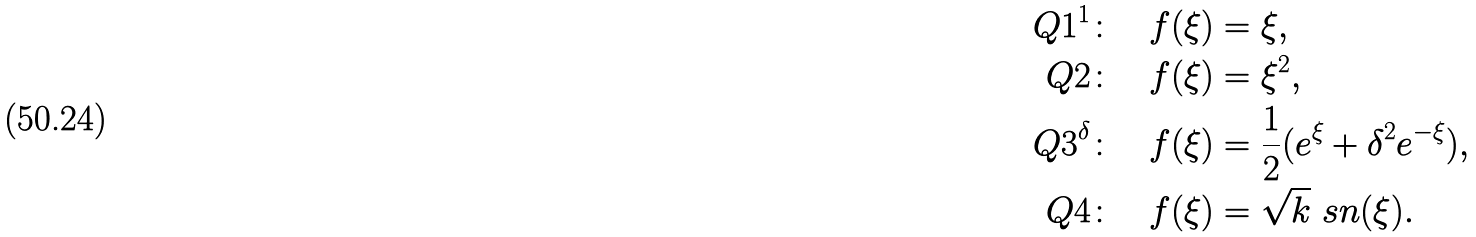<formula> <loc_0><loc_0><loc_500><loc_500>Q 1 ^ { 1 } \colon \quad & f ( \xi ) = \xi , \\ Q 2 \colon \quad & f ( \xi ) = \xi ^ { 2 } , \\ Q 3 ^ { \delta } \colon \quad & f ( \xi ) = \frac { 1 } { 2 } ( e ^ { \xi } + \delta ^ { 2 } e ^ { - \xi } ) , \\ Q 4 \colon \quad & f ( \xi ) = \sqrt { k } \ s n ( \xi ) .</formula> 